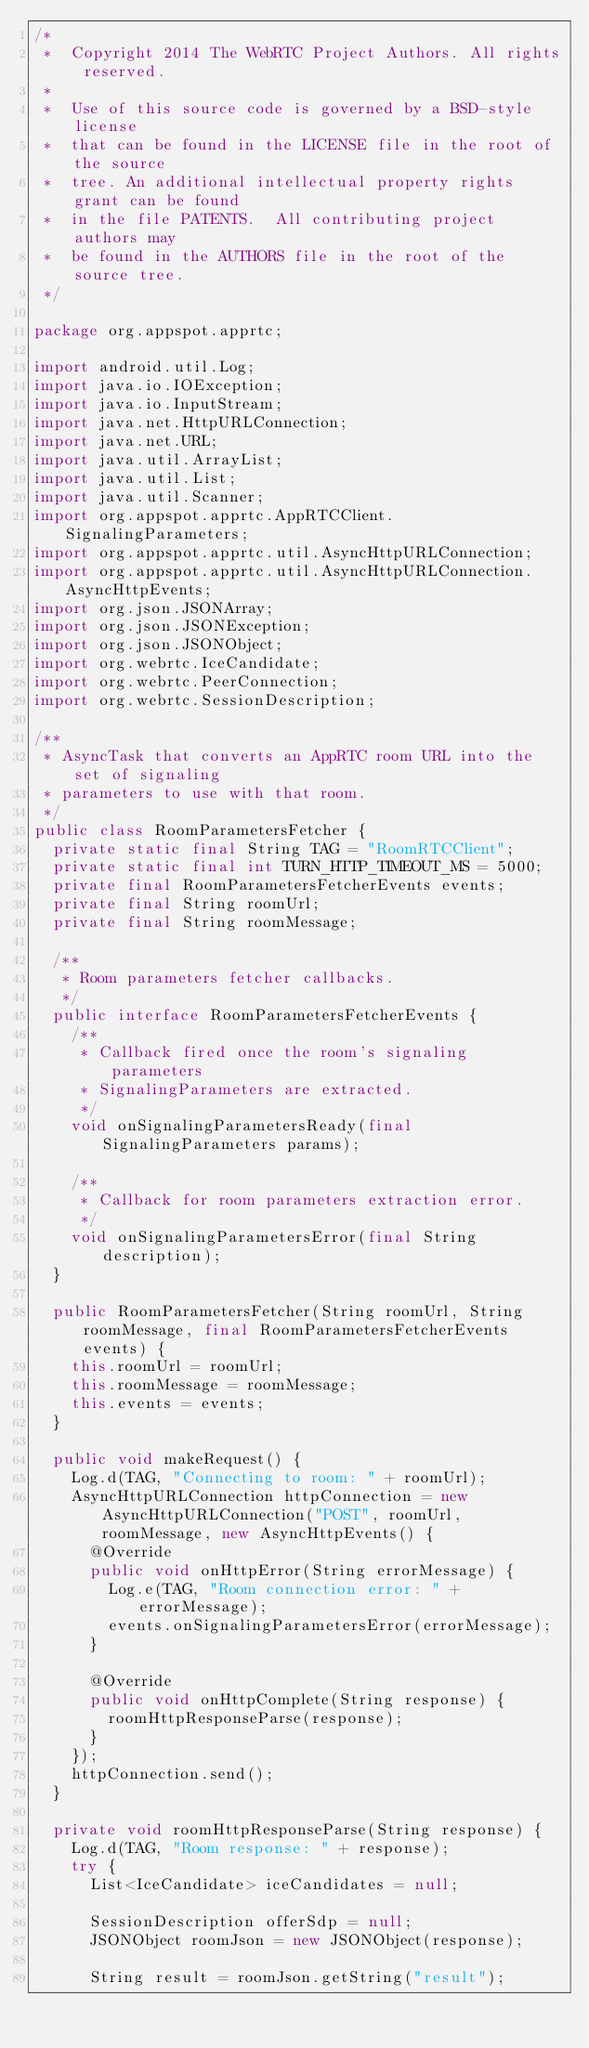Convert code to text. <code><loc_0><loc_0><loc_500><loc_500><_Java_>/*
 *  Copyright 2014 The WebRTC Project Authors. All rights reserved.
 *
 *  Use of this source code is governed by a BSD-style license
 *  that can be found in the LICENSE file in the root of the source
 *  tree. An additional intellectual property rights grant can be found
 *  in the file PATENTS.  All contributing project authors may
 *  be found in the AUTHORS file in the root of the source tree.
 */

package org.appspot.apprtc;

import android.util.Log;
import java.io.IOException;
import java.io.InputStream;
import java.net.HttpURLConnection;
import java.net.URL;
import java.util.ArrayList;
import java.util.List;
import java.util.Scanner;
import org.appspot.apprtc.AppRTCClient.SignalingParameters;
import org.appspot.apprtc.util.AsyncHttpURLConnection;
import org.appspot.apprtc.util.AsyncHttpURLConnection.AsyncHttpEvents;
import org.json.JSONArray;
import org.json.JSONException;
import org.json.JSONObject;
import org.webrtc.IceCandidate;
import org.webrtc.PeerConnection;
import org.webrtc.SessionDescription;

/**
 * AsyncTask that converts an AppRTC room URL into the set of signaling
 * parameters to use with that room.
 */
public class RoomParametersFetcher {
  private static final String TAG = "RoomRTCClient";
  private static final int TURN_HTTP_TIMEOUT_MS = 5000;
  private final RoomParametersFetcherEvents events;
  private final String roomUrl;
  private final String roomMessage;

  /**
   * Room parameters fetcher callbacks.
   */
  public interface RoomParametersFetcherEvents {
    /**
     * Callback fired once the room's signaling parameters
     * SignalingParameters are extracted.
     */
    void onSignalingParametersReady(final SignalingParameters params);

    /**
     * Callback for room parameters extraction error.
     */
    void onSignalingParametersError(final String description);
  }

  public RoomParametersFetcher(String roomUrl, String roomMessage, final RoomParametersFetcherEvents events) {
    this.roomUrl = roomUrl;
    this.roomMessage = roomMessage;
    this.events = events;
  }

  public void makeRequest() {
    Log.d(TAG, "Connecting to room: " + roomUrl);
    AsyncHttpURLConnection httpConnection = new AsyncHttpURLConnection("POST", roomUrl, roomMessage, new AsyncHttpEvents() {
      @Override
      public void onHttpError(String errorMessage) {
        Log.e(TAG, "Room connection error: " + errorMessage);
        events.onSignalingParametersError(errorMessage);
      }

      @Override
      public void onHttpComplete(String response) {
        roomHttpResponseParse(response);
      }
    });
    httpConnection.send();
  }

  private void roomHttpResponseParse(String response) {
    Log.d(TAG, "Room response: " + response);
    try {
      List<IceCandidate> iceCandidates = null;

      SessionDescription offerSdp = null;
      JSONObject roomJson = new JSONObject(response);

      String result = roomJson.getString("result");</code> 